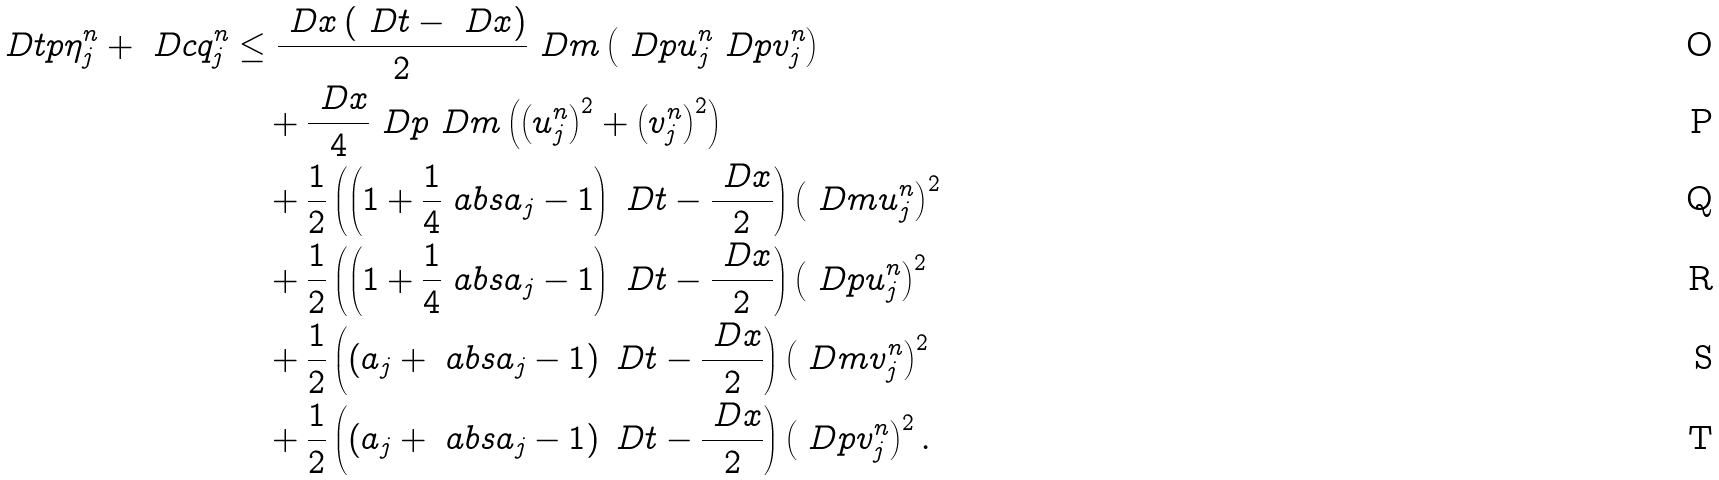<formula> <loc_0><loc_0><loc_500><loc_500>\ D t p \eta ^ { n } _ { j } + \ D c q ^ { n } _ { j } & \leq \frac { \ D x \left ( \ D t - \ D x \right ) } { 2 } \ D m \left ( \ D p u ^ { n } _ { j } \ D p v ^ { n } _ { j } \right ) \\ & \quad + \frac { \ D x } { 4 } \ D p \ D m \left ( \left ( u ^ { n } _ { j } \right ) ^ { 2 } + \left ( v ^ { n } _ { j } \right ) ^ { 2 } \right ) \\ & \quad + \frac { 1 } { 2 } \left ( \left ( 1 + \frac { 1 } { 4 } \ a b s { a _ { j } - 1 } \right ) \ D t - \frac { \ D x } { 2 } \right ) \left ( \ D m u ^ { n } _ { j } \right ) ^ { 2 } \\ & \quad + \frac { 1 } { 2 } \left ( \left ( 1 + \frac { 1 } { 4 } \ a b s { a _ { j } - 1 } \right ) \ D t - \frac { \ D x } { 2 } \right ) \left ( \ D p u ^ { n } _ { j } \right ) ^ { 2 } \\ & \quad + \frac { 1 } { 2 } \left ( \left ( a _ { j } + \ a b s { a _ { j } - 1 } \right ) \ D t - \frac { \ D x } { 2 } \right ) \left ( \ D m v ^ { n } _ { j } \right ) ^ { 2 } \\ & \quad + \frac { 1 } { 2 } \left ( \left ( a _ { j } + \ a b s { a _ { j } - 1 } \right ) \ D t - \frac { \ D x } { 2 } \right ) \left ( \ D p v ^ { n } _ { j } \right ) ^ { 2 } .</formula> 